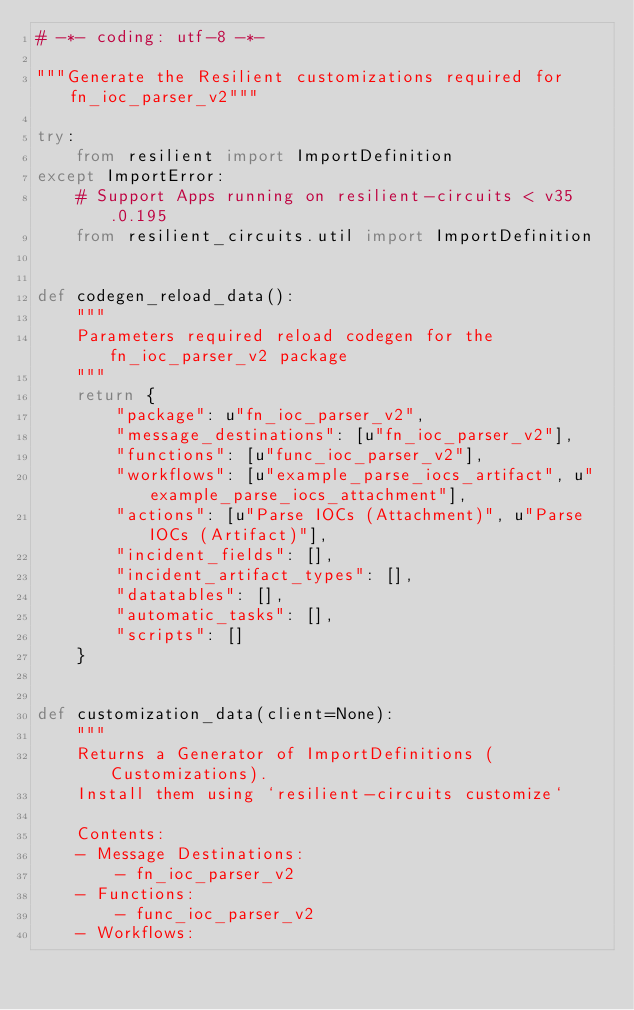<code> <loc_0><loc_0><loc_500><loc_500><_Python_># -*- coding: utf-8 -*-

"""Generate the Resilient customizations required for fn_ioc_parser_v2"""

try:
    from resilient import ImportDefinition
except ImportError:
    # Support Apps running on resilient-circuits < v35.0.195
    from resilient_circuits.util import ImportDefinition


def codegen_reload_data():
    """
    Parameters required reload codegen for the fn_ioc_parser_v2 package
    """
    return {
        "package": u"fn_ioc_parser_v2",
        "message_destinations": [u"fn_ioc_parser_v2"],
        "functions": [u"func_ioc_parser_v2"],
        "workflows": [u"example_parse_iocs_artifact", u"example_parse_iocs_attachment"],
        "actions": [u"Parse IOCs (Attachment)", u"Parse IOCs (Artifact)"],
        "incident_fields": [],
        "incident_artifact_types": [],
        "datatables": [],
        "automatic_tasks": [],
        "scripts": []
    }


def customization_data(client=None):
    """
    Returns a Generator of ImportDefinitions (Customizations).
    Install them using `resilient-circuits customize`

    Contents:
    - Message Destinations:
        - fn_ioc_parser_v2
    - Functions:
        - func_ioc_parser_v2
    - Workflows:</code> 